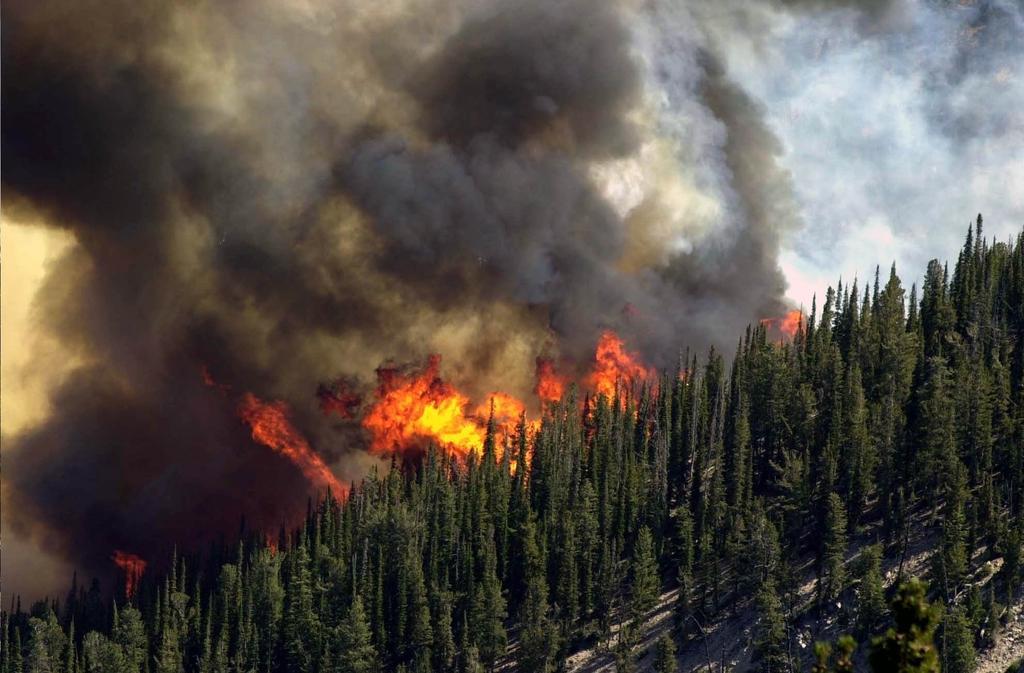In one or two sentences, can you explain what this image depicts? In this image there are so many trees on the mountain, at the back there is some fire and smoke. 